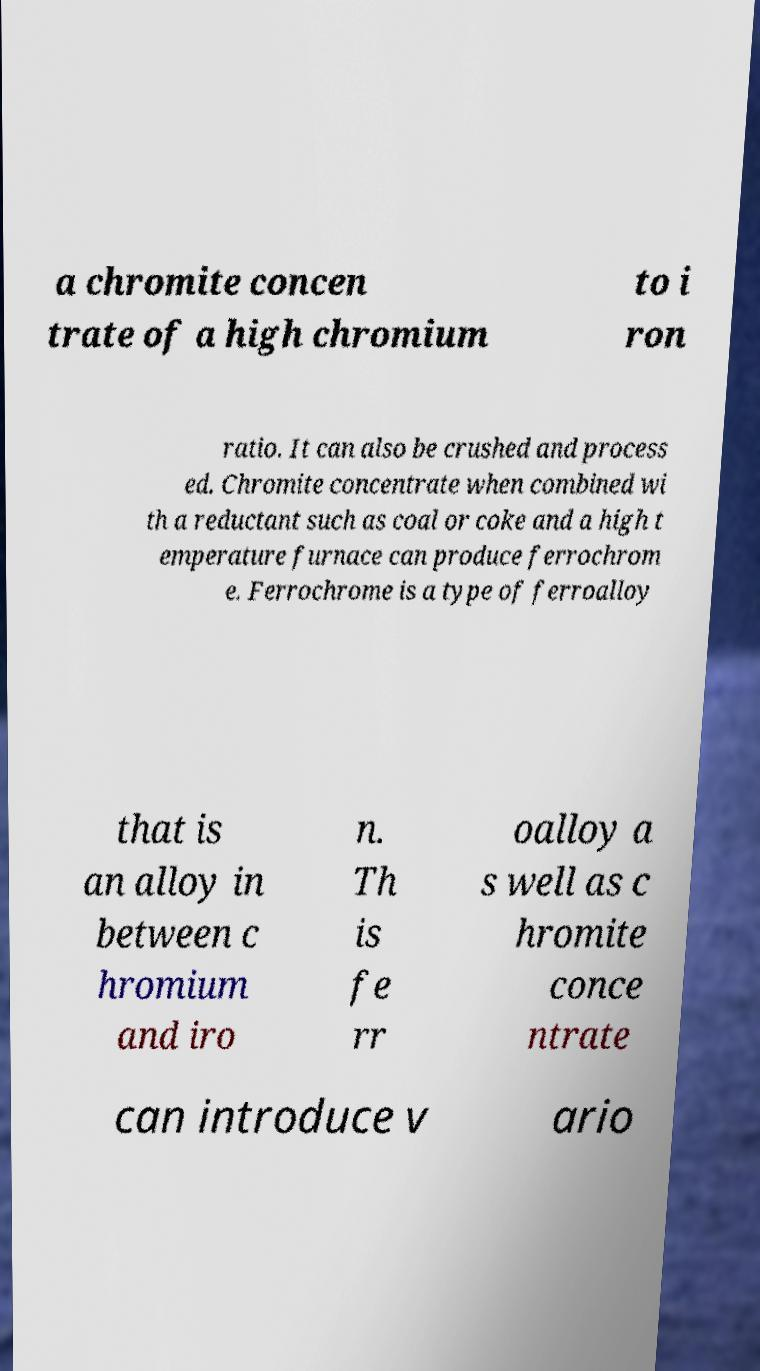Please identify and transcribe the text found in this image. a chromite concen trate of a high chromium to i ron ratio. It can also be crushed and process ed. Chromite concentrate when combined wi th a reductant such as coal or coke and a high t emperature furnace can produce ferrochrom e. Ferrochrome is a type of ferroalloy that is an alloy in between c hromium and iro n. Th is fe rr oalloy a s well as c hromite conce ntrate can introduce v ario 